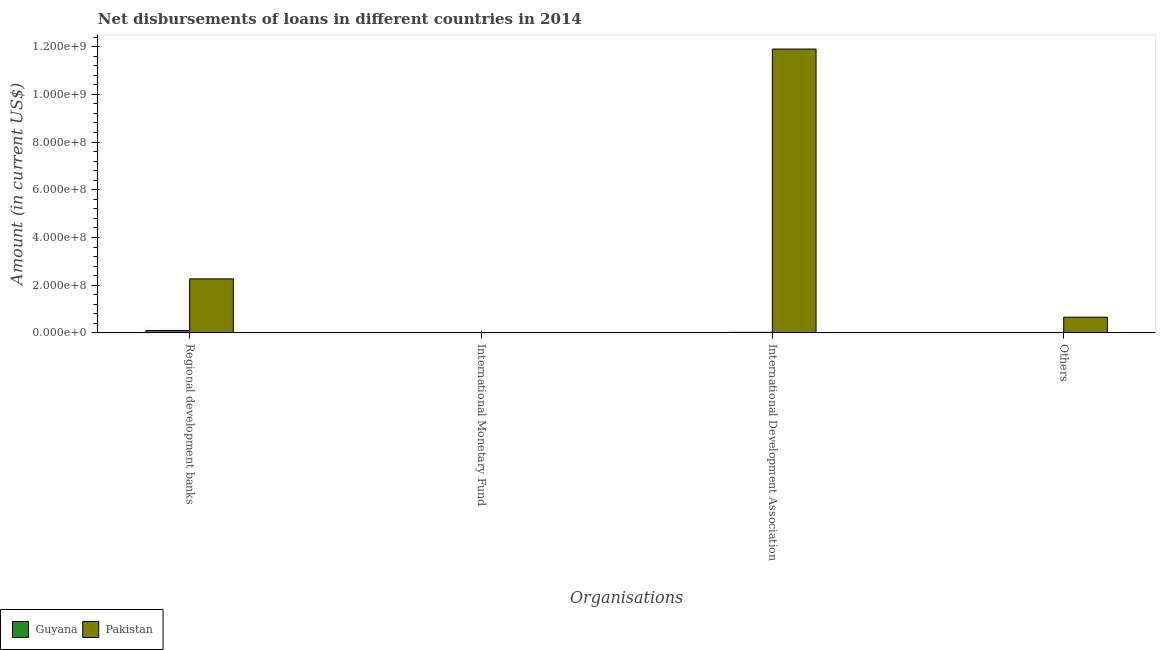How many bars are there on the 1st tick from the left?
Make the answer very short. 2. How many bars are there on the 2nd tick from the right?
Provide a succinct answer. 2. What is the label of the 2nd group of bars from the left?
Make the answer very short. International Monetary Fund. What is the amount of loan disimbursed by regional development banks in Pakistan?
Your answer should be compact. 2.26e+08. Across all countries, what is the maximum amount of loan disimbursed by regional development banks?
Your response must be concise. 2.26e+08. Across all countries, what is the minimum amount of loan disimbursed by international development association?
Provide a short and direct response. 2.19e+06. In which country was the amount of loan disimbursed by international development association maximum?
Ensure brevity in your answer.  Pakistan. What is the total amount of loan disimbursed by international development association in the graph?
Your answer should be compact. 1.19e+09. What is the difference between the amount of loan disimbursed by regional development banks in Guyana and that in Pakistan?
Keep it short and to the point. -2.16e+08. What is the difference between the amount of loan disimbursed by regional development banks in Pakistan and the amount of loan disimbursed by international development association in Guyana?
Offer a very short reply. 2.24e+08. What is the average amount of loan disimbursed by international development association per country?
Your response must be concise. 5.96e+08. What is the difference between the amount of loan disimbursed by other organisations and amount of loan disimbursed by international development association in Guyana?
Give a very brief answer. -8.79e+05. In how many countries, is the amount of loan disimbursed by international development association greater than 360000000 US$?
Make the answer very short. 1. What is the ratio of the amount of loan disimbursed by other organisations in Pakistan to that in Guyana?
Your answer should be very brief. 50.27. What is the difference between the highest and the second highest amount of loan disimbursed by other organisations?
Your answer should be very brief. 6.45e+07. What is the difference between the highest and the lowest amount of loan disimbursed by other organisations?
Your response must be concise. 6.45e+07. In how many countries, is the amount of loan disimbursed by international monetary fund greater than the average amount of loan disimbursed by international monetary fund taken over all countries?
Provide a succinct answer. 0. Is the sum of the amount of loan disimbursed by regional development banks in Guyana and Pakistan greater than the maximum amount of loan disimbursed by international development association across all countries?
Offer a terse response. No. How many bars are there?
Make the answer very short. 6. Are all the bars in the graph horizontal?
Your answer should be compact. No. What is the difference between two consecutive major ticks on the Y-axis?
Provide a short and direct response. 2.00e+08. Are the values on the major ticks of Y-axis written in scientific E-notation?
Your response must be concise. Yes. Does the graph contain grids?
Your answer should be very brief. No. Where does the legend appear in the graph?
Your answer should be very brief. Bottom left. What is the title of the graph?
Provide a succinct answer. Net disbursements of loans in different countries in 2014. What is the label or title of the X-axis?
Your response must be concise. Organisations. What is the Amount (in current US$) in Guyana in Regional development banks?
Give a very brief answer. 1.00e+07. What is the Amount (in current US$) of Pakistan in Regional development banks?
Provide a succinct answer. 2.26e+08. What is the Amount (in current US$) of Guyana in International Development Association?
Provide a short and direct response. 2.19e+06. What is the Amount (in current US$) in Pakistan in International Development Association?
Provide a short and direct response. 1.19e+09. What is the Amount (in current US$) in Guyana in Others?
Give a very brief answer. 1.31e+06. What is the Amount (in current US$) in Pakistan in Others?
Provide a succinct answer. 6.58e+07. Across all Organisations, what is the maximum Amount (in current US$) in Guyana?
Your response must be concise. 1.00e+07. Across all Organisations, what is the maximum Amount (in current US$) of Pakistan?
Offer a very short reply. 1.19e+09. What is the total Amount (in current US$) in Guyana in the graph?
Provide a short and direct response. 1.35e+07. What is the total Amount (in current US$) in Pakistan in the graph?
Keep it short and to the point. 1.48e+09. What is the difference between the Amount (in current US$) in Guyana in Regional development banks and that in International Development Association?
Provide a short and direct response. 7.84e+06. What is the difference between the Amount (in current US$) of Pakistan in Regional development banks and that in International Development Association?
Give a very brief answer. -9.64e+08. What is the difference between the Amount (in current US$) in Guyana in Regional development banks and that in Others?
Your response must be concise. 8.72e+06. What is the difference between the Amount (in current US$) of Pakistan in Regional development banks and that in Others?
Keep it short and to the point. 1.61e+08. What is the difference between the Amount (in current US$) of Guyana in International Development Association and that in Others?
Ensure brevity in your answer.  8.79e+05. What is the difference between the Amount (in current US$) of Pakistan in International Development Association and that in Others?
Make the answer very short. 1.12e+09. What is the difference between the Amount (in current US$) of Guyana in Regional development banks and the Amount (in current US$) of Pakistan in International Development Association?
Your answer should be very brief. -1.18e+09. What is the difference between the Amount (in current US$) in Guyana in Regional development banks and the Amount (in current US$) in Pakistan in Others?
Provide a succinct answer. -5.58e+07. What is the difference between the Amount (in current US$) in Guyana in International Development Association and the Amount (in current US$) in Pakistan in Others?
Provide a short and direct response. -6.36e+07. What is the average Amount (in current US$) of Guyana per Organisations?
Provide a succinct answer. 3.38e+06. What is the average Amount (in current US$) in Pakistan per Organisations?
Offer a terse response. 3.71e+08. What is the difference between the Amount (in current US$) in Guyana and Amount (in current US$) in Pakistan in Regional development banks?
Keep it short and to the point. -2.16e+08. What is the difference between the Amount (in current US$) in Guyana and Amount (in current US$) in Pakistan in International Development Association?
Your answer should be very brief. -1.19e+09. What is the difference between the Amount (in current US$) in Guyana and Amount (in current US$) in Pakistan in Others?
Give a very brief answer. -6.45e+07. What is the ratio of the Amount (in current US$) of Guyana in Regional development banks to that in International Development Association?
Offer a terse response. 4.58. What is the ratio of the Amount (in current US$) in Pakistan in Regional development banks to that in International Development Association?
Make the answer very short. 0.19. What is the ratio of the Amount (in current US$) in Guyana in Regional development banks to that in Others?
Your answer should be compact. 7.66. What is the ratio of the Amount (in current US$) in Pakistan in Regional development banks to that in Others?
Offer a very short reply. 3.44. What is the ratio of the Amount (in current US$) of Guyana in International Development Association to that in Others?
Your answer should be compact. 1.67. What is the ratio of the Amount (in current US$) in Pakistan in International Development Association to that in Others?
Offer a terse response. 18.08. What is the difference between the highest and the second highest Amount (in current US$) of Guyana?
Offer a terse response. 7.84e+06. What is the difference between the highest and the second highest Amount (in current US$) of Pakistan?
Provide a short and direct response. 9.64e+08. What is the difference between the highest and the lowest Amount (in current US$) in Guyana?
Ensure brevity in your answer.  1.00e+07. What is the difference between the highest and the lowest Amount (in current US$) of Pakistan?
Your answer should be very brief. 1.19e+09. 